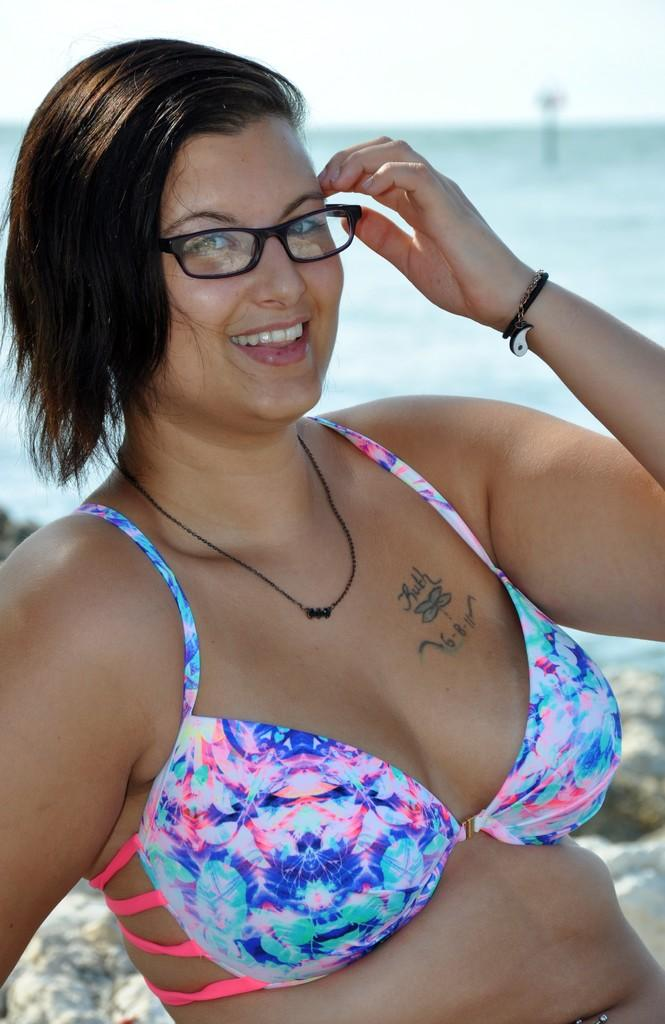Who is the main subject in the image? There is a woman in the center of the image. What is the woman wearing in the image? The woman is wearing spectacles in the image. What can be seen in the background of the image? Water and the sky are visible in the background of the image. What note is the woman holding in the image? There is no note present in the image; the woman is not holding anything. 